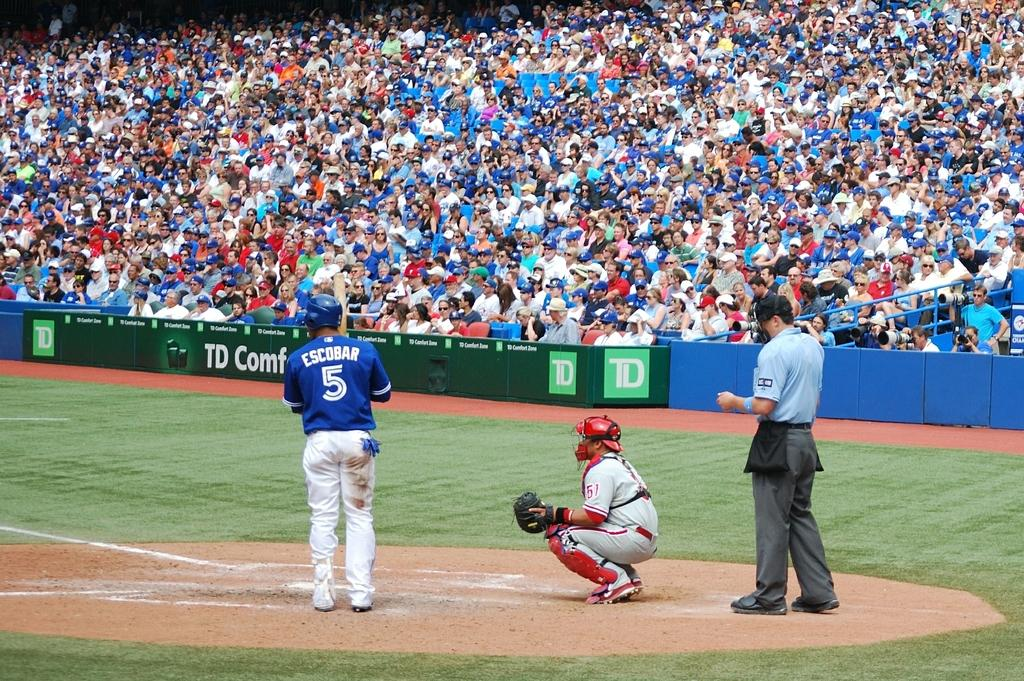<image>
Relay a brief, clear account of the picture shown. TD logo in green on a banner on the football field. 